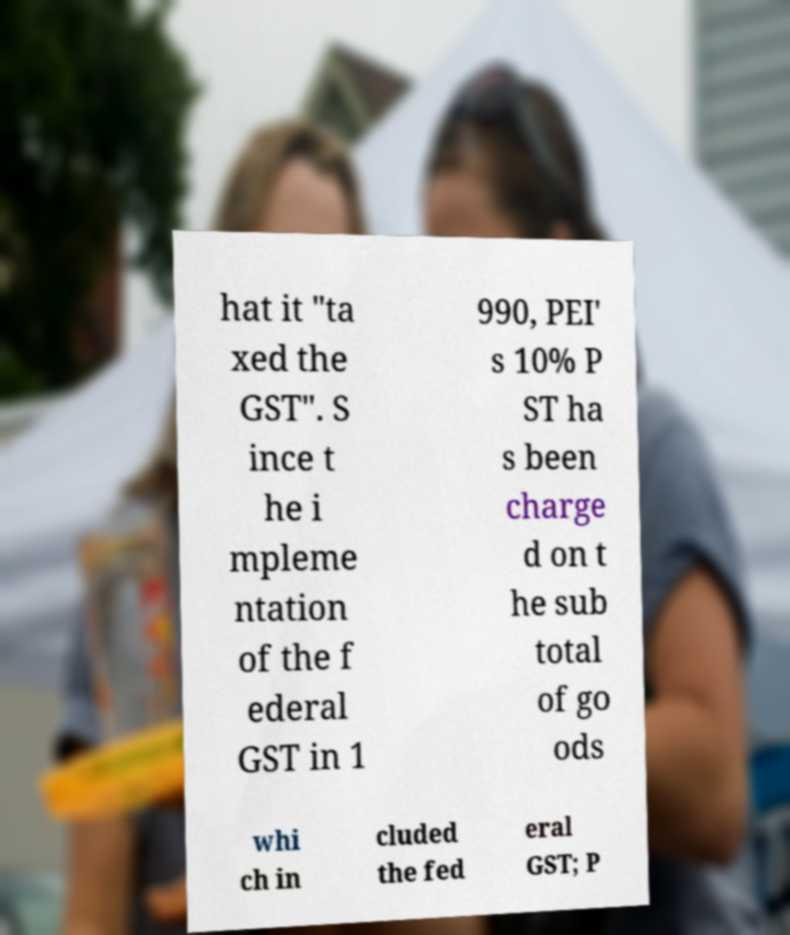Please read and relay the text visible in this image. What does it say? hat it "ta xed the GST". S ince t he i mpleme ntation of the f ederal GST in 1 990, PEI' s 10% P ST ha s been charge d on t he sub total of go ods whi ch in cluded the fed eral GST; P 